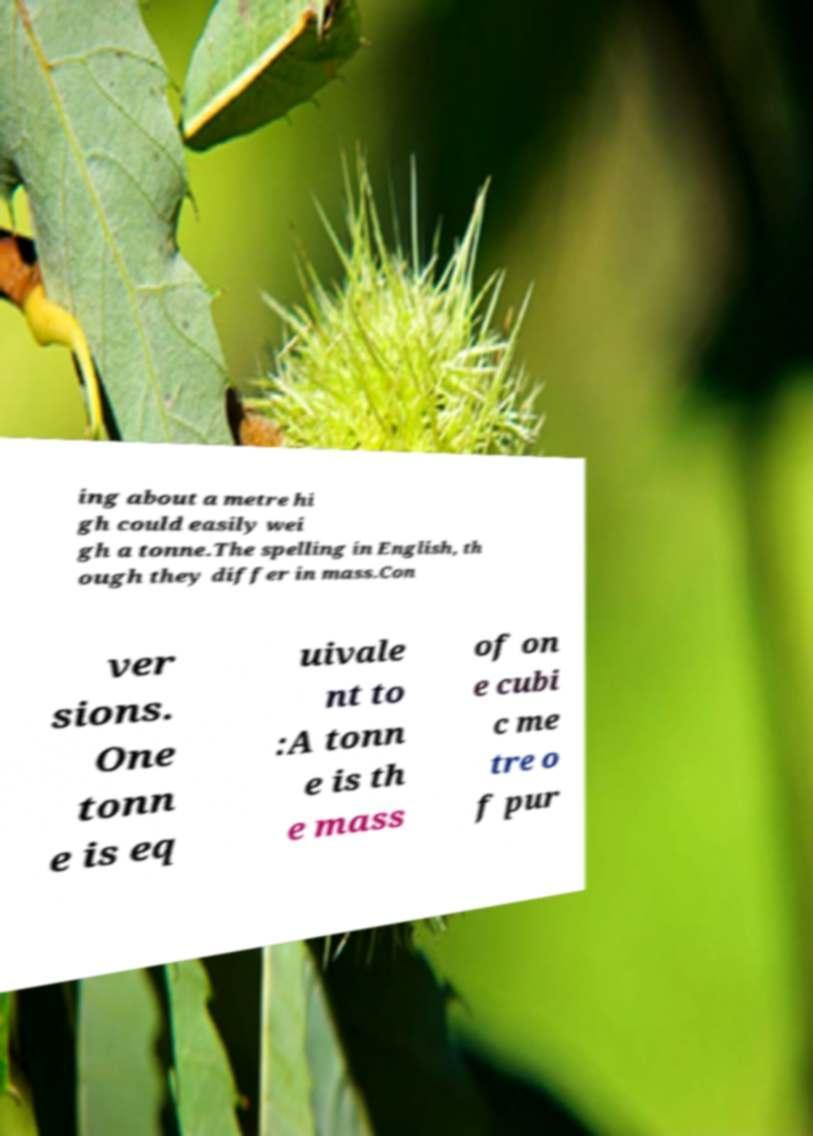Please identify and transcribe the text found in this image. ing about a metre hi gh could easily wei gh a tonne.The spelling in English, th ough they differ in mass.Con ver sions. One tonn e is eq uivale nt to :A tonn e is th e mass of on e cubi c me tre o f pur 